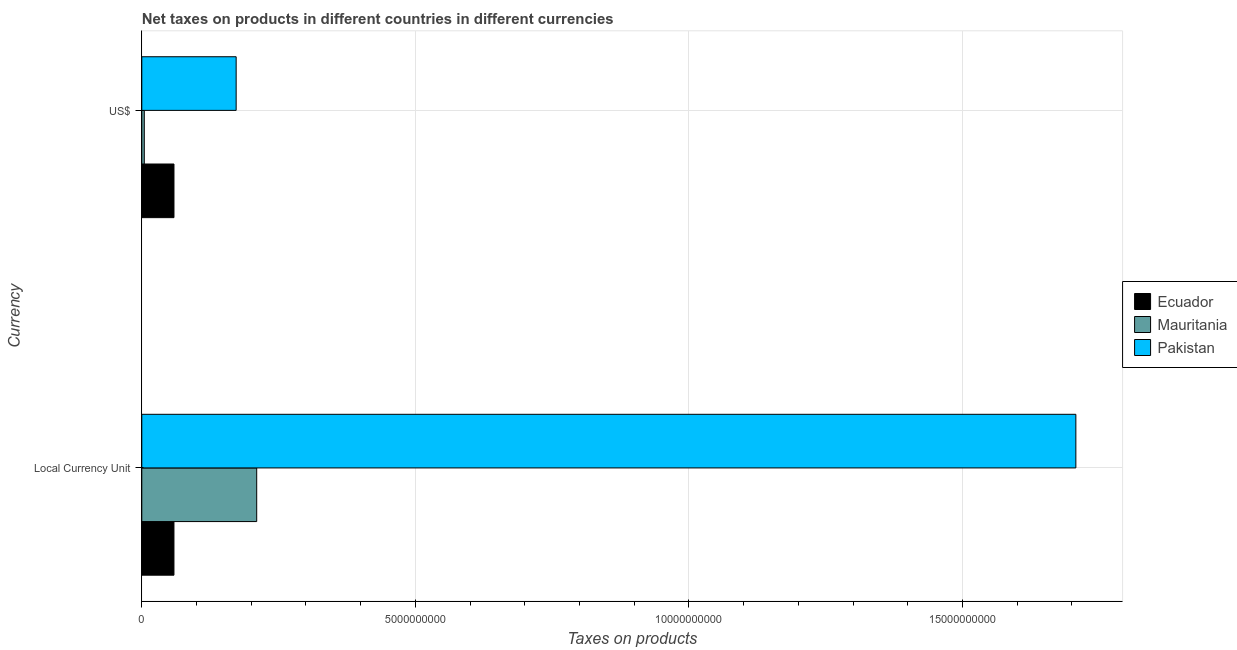How many groups of bars are there?
Make the answer very short. 2. How many bars are there on the 2nd tick from the bottom?
Make the answer very short. 3. What is the label of the 2nd group of bars from the top?
Provide a succinct answer. Local Currency Unit. What is the net taxes in us$ in Pakistan?
Your response must be concise. 1.72e+09. Across all countries, what is the maximum net taxes in us$?
Provide a succinct answer. 1.72e+09. Across all countries, what is the minimum net taxes in us$?
Offer a very short reply. 4.58e+07. In which country was the net taxes in constant 2005 us$ minimum?
Give a very brief answer. Ecuador. What is the total net taxes in us$ in the graph?
Provide a succinct answer. 2.36e+09. What is the difference between the net taxes in us$ in Mauritania and that in Ecuador?
Provide a short and direct response. -5.42e+08. What is the difference between the net taxes in constant 2005 us$ in Mauritania and the net taxes in us$ in Ecuador?
Provide a succinct answer. 1.51e+09. What is the average net taxes in constant 2005 us$ per country?
Give a very brief answer. 6.59e+09. What is the difference between the net taxes in us$ and net taxes in constant 2005 us$ in Mauritania?
Offer a very short reply. -2.05e+09. In how many countries, is the net taxes in constant 2005 us$ greater than 7000000000 units?
Offer a terse response. 1. What is the ratio of the net taxes in us$ in Mauritania to that in Ecuador?
Your answer should be very brief. 0.08. Is the net taxes in us$ in Ecuador less than that in Pakistan?
Give a very brief answer. Yes. In how many countries, is the net taxes in constant 2005 us$ greater than the average net taxes in constant 2005 us$ taken over all countries?
Offer a very short reply. 1. What does the 2nd bar from the top in Local Currency Unit represents?
Make the answer very short. Mauritania. How many countries are there in the graph?
Your response must be concise. 3. Are the values on the major ticks of X-axis written in scientific E-notation?
Provide a succinct answer. No. Does the graph contain grids?
Provide a succinct answer. Yes. Where does the legend appear in the graph?
Provide a succinct answer. Center right. How are the legend labels stacked?
Keep it short and to the point. Vertical. What is the title of the graph?
Your response must be concise. Net taxes on products in different countries in different currencies. Does "Middle income" appear as one of the legend labels in the graph?
Provide a short and direct response. No. What is the label or title of the X-axis?
Give a very brief answer. Taxes on products. What is the label or title of the Y-axis?
Offer a very short reply. Currency. What is the Taxes on products in Ecuador in Local Currency Unit?
Keep it short and to the point. 5.88e+08. What is the Taxes on products of Mauritania in Local Currency Unit?
Ensure brevity in your answer.  2.10e+09. What is the Taxes on products of Pakistan in Local Currency Unit?
Make the answer very short. 1.71e+1. What is the Taxes on products of Ecuador in US$?
Ensure brevity in your answer.  5.88e+08. What is the Taxes on products in Mauritania in US$?
Your response must be concise. 4.58e+07. What is the Taxes on products in Pakistan in US$?
Ensure brevity in your answer.  1.72e+09. Across all Currency, what is the maximum Taxes on products of Ecuador?
Your answer should be compact. 5.88e+08. Across all Currency, what is the maximum Taxes on products in Mauritania?
Provide a short and direct response. 2.10e+09. Across all Currency, what is the maximum Taxes on products in Pakistan?
Ensure brevity in your answer.  1.71e+1. Across all Currency, what is the minimum Taxes on products in Ecuador?
Ensure brevity in your answer.  5.88e+08. Across all Currency, what is the minimum Taxes on products of Mauritania?
Provide a short and direct response. 4.58e+07. Across all Currency, what is the minimum Taxes on products of Pakistan?
Make the answer very short. 1.72e+09. What is the total Taxes on products in Ecuador in the graph?
Keep it short and to the point. 1.18e+09. What is the total Taxes on products in Mauritania in the graph?
Your answer should be very brief. 2.15e+09. What is the total Taxes on products in Pakistan in the graph?
Provide a succinct answer. 1.88e+1. What is the difference between the Taxes on products of Ecuador in Local Currency Unit and that in US$?
Offer a very short reply. -2.82e+05. What is the difference between the Taxes on products of Mauritania in Local Currency Unit and that in US$?
Give a very brief answer. 2.05e+09. What is the difference between the Taxes on products of Pakistan in Local Currency Unit and that in US$?
Offer a terse response. 1.53e+1. What is the difference between the Taxes on products of Ecuador in Local Currency Unit and the Taxes on products of Mauritania in US$?
Make the answer very short. 5.42e+08. What is the difference between the Taxes on products of Ecuador in Local Currency Unit and the Taxes on products of Pakistan in US$?
Offer a terse response. -1.14e+09. What is the difference between the Taxes on products in Mauritania in Local Currency Unit and the Taxes on products in Pakistan in US$?
Your answer should be very brief. 3.76e+08. What is the average Taxes on products in Ecuador per Currency?
Offer a terse response. 5.88e+08. What is the average Taxes on products in Mauritania per Currency?
Provide a short and direct response. 1.07e+09. What is the average Taxes on products of Pakistan per Currency?
Provide a succinct answer. 9.40e+09. What is the difference between the Taxes on products in Ecuador and Taxes on products in Mauritania in Local Currency Unit?
Offer a terse response. -1.51e+09. What is the difference between the Taxes on products of Ecuador and Taxes on products of Pakistan in Local Currency Unit?
Make the answer very short. -1.65e+1. What is the difference between the Taxes on products in Mauritania and Taxes on products in Pakistan in Local Currency Unit?
Offer a terse response. -1.50e+1. What is the difference between the Taxes on products in Ecuador and Taxes on products in Mauritania in US$?
Make the answer very short. 5.42e+08. What is the difference between the Taxes on products in Ecuador and Taxes on products in Pakistan in US$?
Offer a terse response. -1.14e+09. What is the difference between the Taxes on products of Mauritania and Taxes on products of Pakistan in US$?
Ensure brevity in your answer.  -1.68e+09. What is the ratio of the Taxes on products in Ecuador in Local Currency Unit to that in US$?
Your answer should be very brief. 1. What is the ratio of the Taxes on products in Mauritania in Local Currency Unit to that in US$?
Provide a succinct answer. 45.89. What is the ratio of the Taxes on products of Pakistan in Local Currency Unit to that in US$?
Your answer should be compact. 9.9. What is the difference between the highest and the second highest Taxes on products in Ecuador?
Make the answer very short. 2.82e+05. What is the difference between the highest and the second highest Taxes on products in Mauritania?
Make the answer very short. 2.05e+09. What is the difference between the highest and the second highest Taxes on products in Pakistan?
Offer a very short reply. 1.53e+1. What is the difference between the highest and the lowest Taxes on products of Ecuador?
Offer a very short reply. 2.82e+05. What is the difference between the highest and the lowest Taxes on products in Mauritania?
Ensure brevity in your answer.  2.05e+09. What is the difference between the highest and the lowest Taxes on products in Pakistan?
Your answer should be compact. 1.53e+1. 